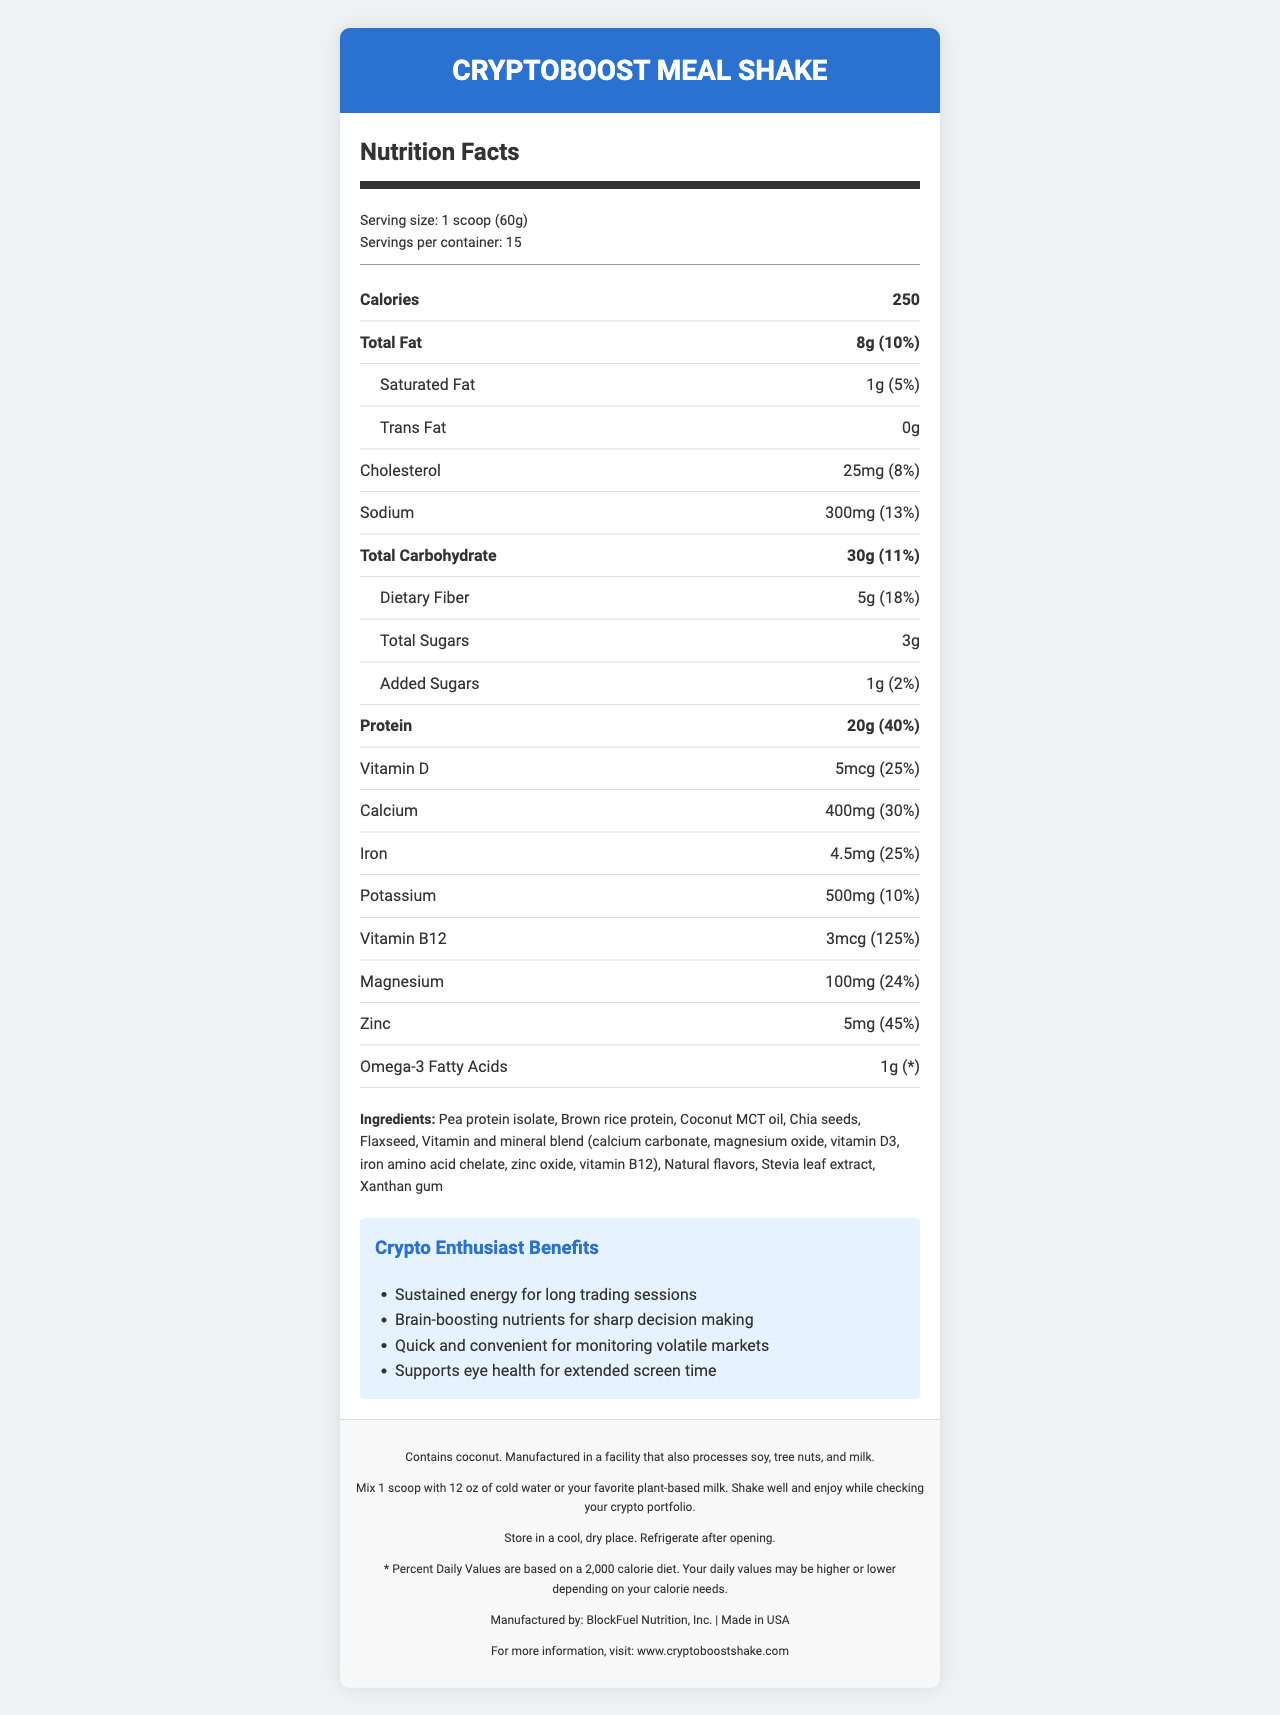what is the serving size? The document mentions "Serving size: 1 scoop (60g)" in the serving-info section.
Answer: 1 scoop (60g) how many calories are in one serving? The document lists "Calories 250" prominently in the nutrition facts section.
Answer: 250 how many servings are in one container? The document states "Servings per container: 15" in the serving-info section.
Answer: 15 how much protein is in each serving? The document states "Protein 20g (40%)" in the nutrition facts.
Answer: 20g what percentage of the daily value of Vitamin B12 does one serving provide? The document shows "Vitamin B12 3mcg (125%)" in the nutrition facts.
Answer: 125% which ingredient is listed first? The document lists the ingredients in order: "Pea protein isolate, Brown rice protein, Coconut MCT oil, etc."
Answer: Pea protein isolate what are the potential allergens in the product? The allergen information section of the document states: "Contains coconut. Manufactured in a facility that also processes soy, tree nuts, and milk."
Answer: Coconut, soy, tree nuts, and milk how should the product be stored after opening? The storage section mentions: "Refrigerate after opening."
Answer: Refrigerate after opening what is the total amount of carbohydrates per serving? A. 25g B. 30g C. 35g The document states "Total Carbohydrate 30g (11%)" in the nutrition facts.
Answer: B what is the suggested usage for this product? A. Mix with hot water B. Blend with fruit smoothies C. Mix with cold water or plant-based milk The usage instructions state: "Mix 1 scoop with 12 oz of cold water or your favorite plant-based milk. Shake well and enjoy while checking your crypto portfolio."
Answer: C is this product made in the USA? The footer of the document says "Made in USA."
Answer: Yes does this product contain added sugars? The document lists "Added Sugars 1g (2%)" in the nutrition facts.
Answer: Yes summarize the main benefits of the CryptoBoost Meal Shake for crypto enthusiasts The benefits section highlights these key points, elaborating on their relevance to crypto enthusiasts' needs.
Answer: The CryptoBoost Meal Shake offers benefits like sustained energy for long trading sessions, brain-boosting nutrients for sharp decision-making, quick and convenient preparation for monitoring volatile markets, and support for eye health during extended screen time. how many milligrams of calcium are in one serving? The document shows "Calcium 400mg (30%)" in the nutrition facts.
Answer: 400mg how many calories from fat are in one serving? The document does not provide specific calorie information from fat, only total calories and fat content.
Answer: Not enough information which company manufactures the CryptoBoost Meal Shake? The footer states that the product is manufactured by "BlockFuel Nutrition, Inc."
Answer: BlockFuel Nutrition, Inc. 